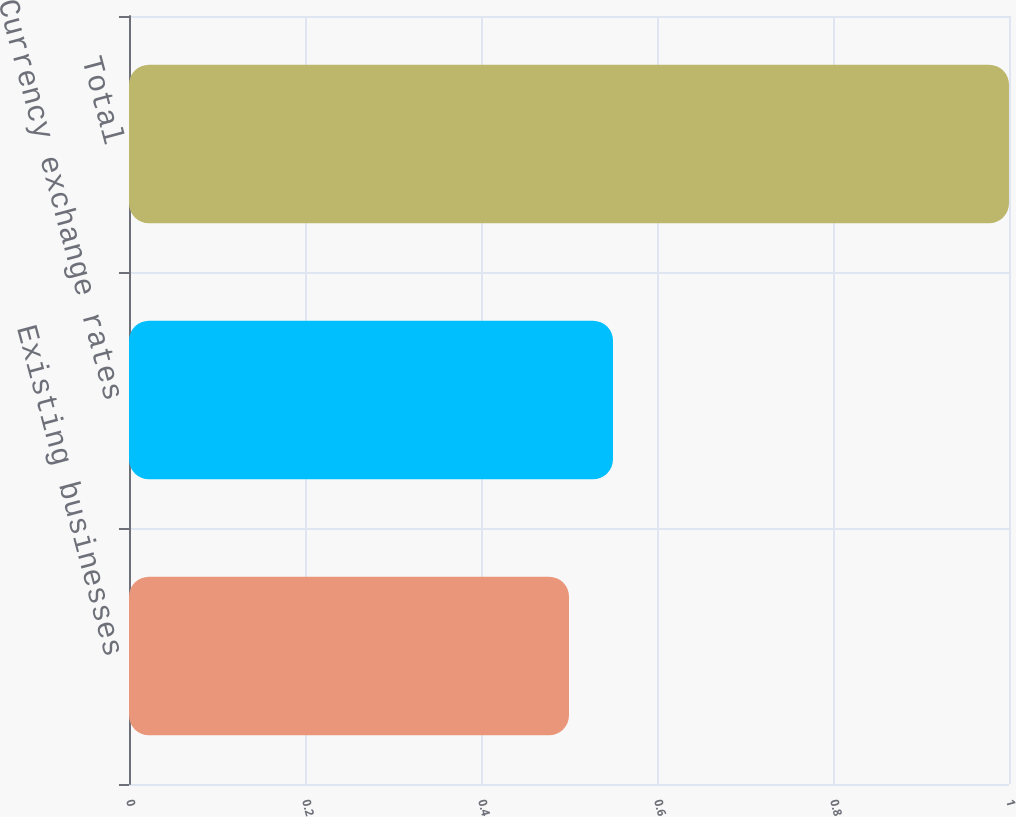Convert chart. <chart><loc_0><loc_0><loc_500><loc_500><bar_chart><fcel>Existing businesses<fcel>Currency exchange rates<fcel>Total<nl><fcel>0.5<fcel>0.55<fcel>1<nl></chart> 